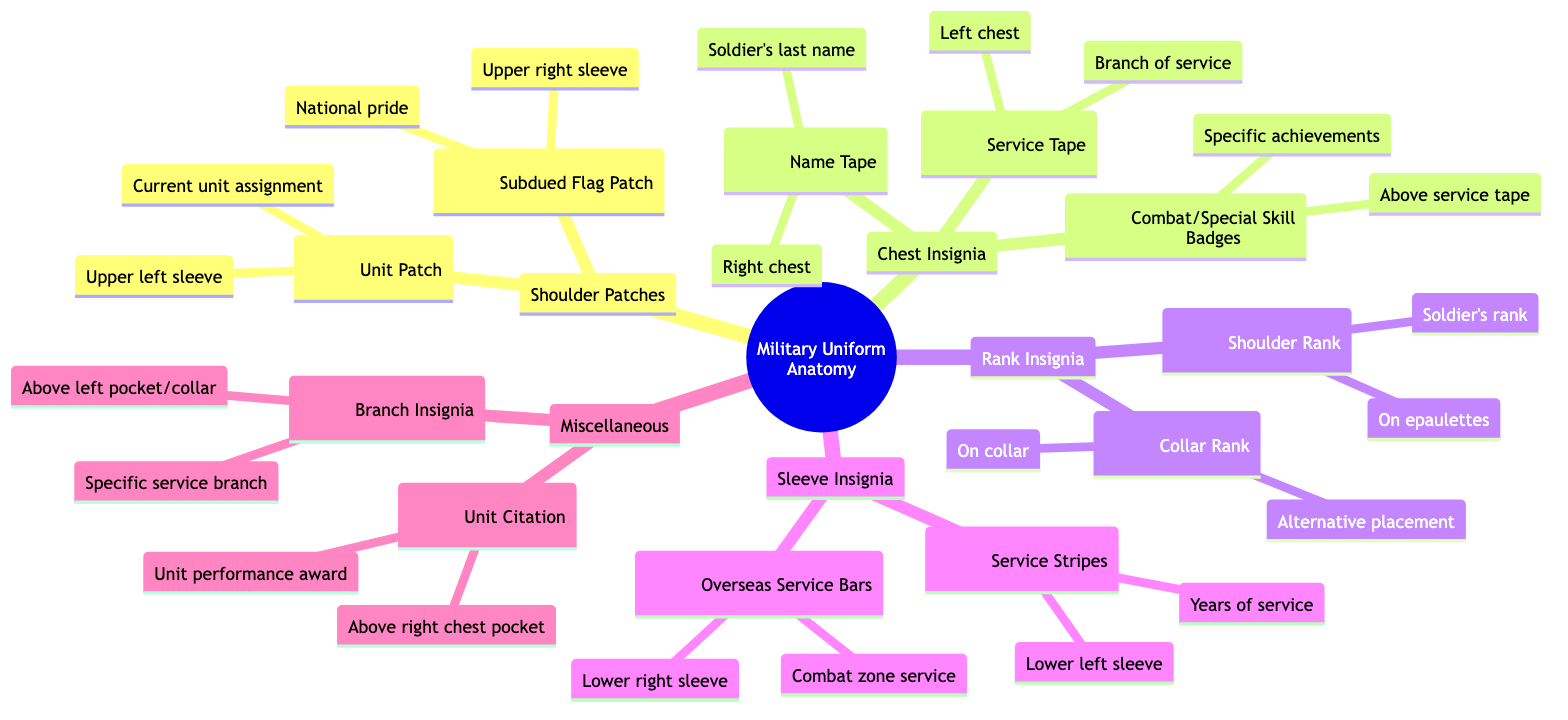What patch is located on the upper left sleeve? The diagram indicates that the unit patch is located on the upper left sleeve. This patch denotes the soldier's current unit assignment, which is a critical piece of identification in the military context.
Answer: Unit Patch What symbol represents the soldier's last name? According to the diagram, the name tape, represented by a specific icon, is found on the right chest area of the military uniform. This is where the soldier's last name is displayed prominently.
Answer: Name Tape How many types of sleeve insignia are mentioned in the diagram? The diagram lists two specific types of sleeve insignia: service stripes and overseas service bars. Summing these gives a total of two distinct types of sleeve insignia present in the diagram.
Answer: 2 What is the significance of the subdued flag patch? The subdued flag patch is associated with national pride and is positioned on the upper right sleeve of the military uniform. This symbolizes the soldier's allegiance to their country.
Answer: National pride In which position is the combat/special skill badge located? Referring to the diagram, the combat/special skill badge is placed above the service tape on the chest of the uniform. This positioning indicates that it is part of the key insignia displayed on the front of the uniform.
Answer: Above service tape Which insignia is associated with years of service? The diagram specifies that service stripes are associated with the years of service for a soldier and are located on the lower left sleeve. Each stripe represents a certain amount of service time.
Answer: Service Stripes What does the unit citation signify on the uniform? The diagram shows that the unit citation, located above the right chest pocket, is an award representing the performance of a unit. It acknowledges the accomplishments and service of the entire unit rather than just the individual.
Answer: Unit performance award What information does the collar rank provide? The collar rank, found on the collar area of the uniform, provides information on the soldier's rank. This allows for quick identification of the soldier's rank by others.
Answer: Soldier's rank What is the placement of the branch insignia? As illustrated in the diagram, the branch insignia is positioned above the left pocket or collar of the uniform. This insignia signifies the specific service branch to which the soldier belongs.
Answer: Above left pocket/collar 